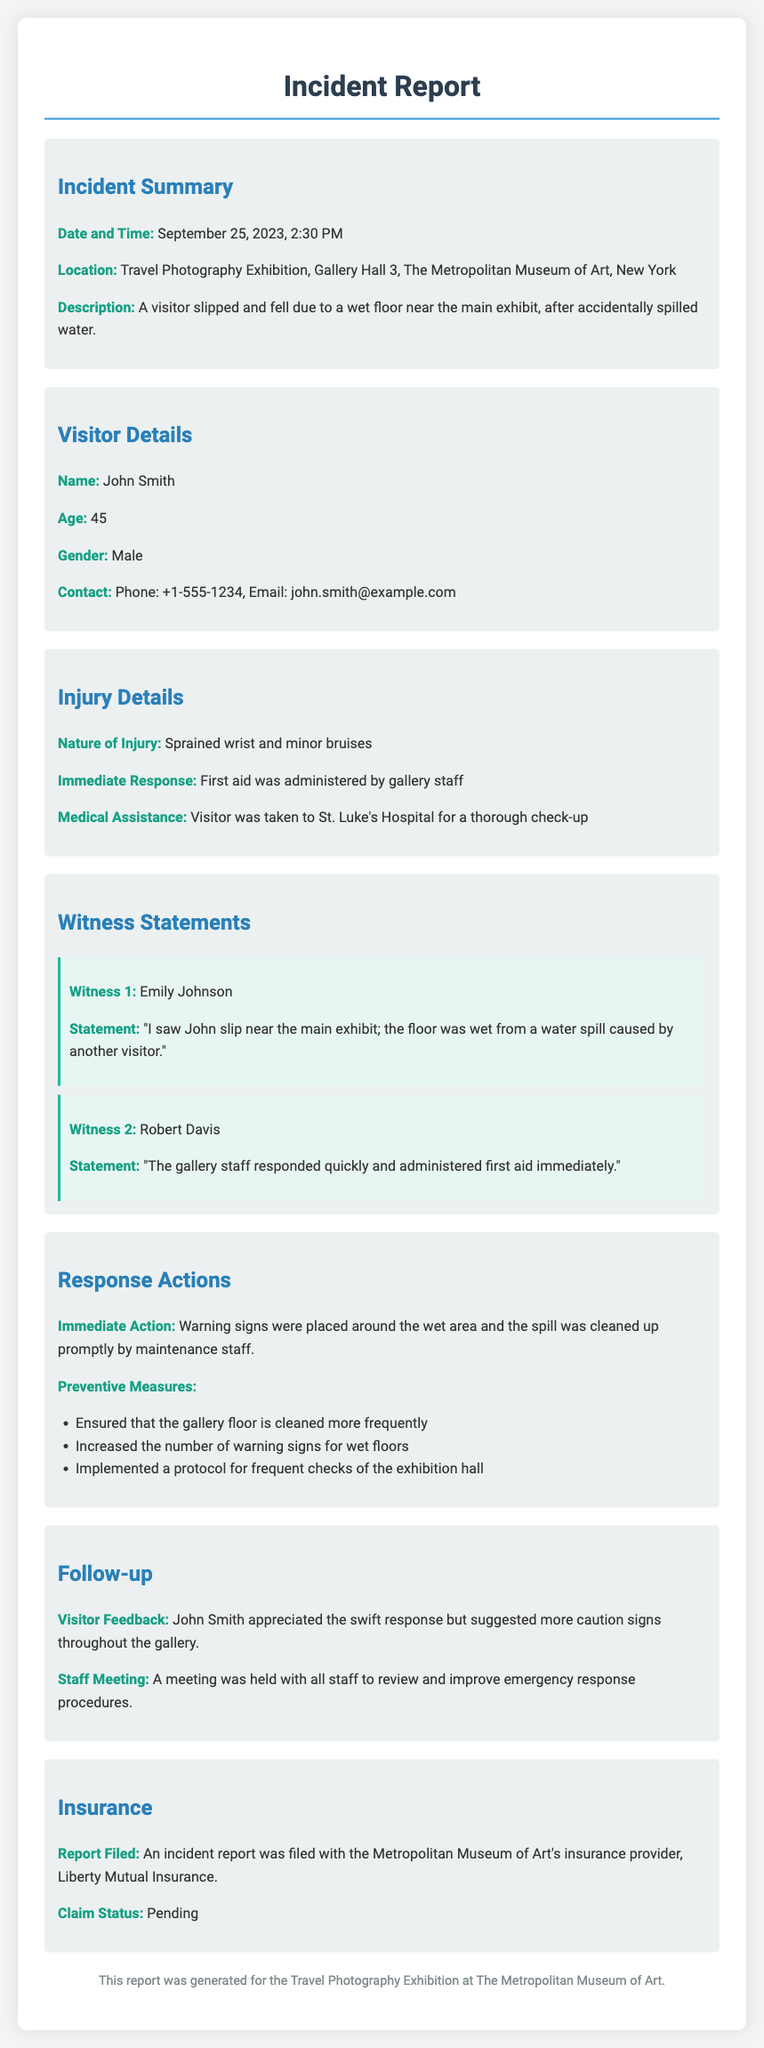what is the date of the incident? The incident occurred on September 25, 2023.
Answer: September 25, 2023 where did the incident take place? The incident took place in Gallery Hall 3 at The Metropolitan Museum of Art.
Answer: Gallery Hall 3, The Metropolitan Museum of Art who was the visitor involved in the injury? The injured visitor's name is John Smith.
Answer: John Smith what injury did the visitor sustain? The visitor sustained a sprained wrist and minor bruises.
Answer: Sprained wrist and minor bruises what immediate action was taken after the incident? Warning signs were placed around the wet area and the spill was cleaned up promptly.
Answer: Warning signs were placed and the spill was cleaned how did the witnesses describe the incident? The witnesses noted that the floor was wet from a spill caused by another visitor.
Answer: The floor was wet from a spill what follow-up action was taken regarding the staff? A meeting was held with all staff to review and improve emergency response procedures.
Answer: Staff meeting was held what is the claim status with the insurance provider? The claim status is currently pending.
Answer: Pending 